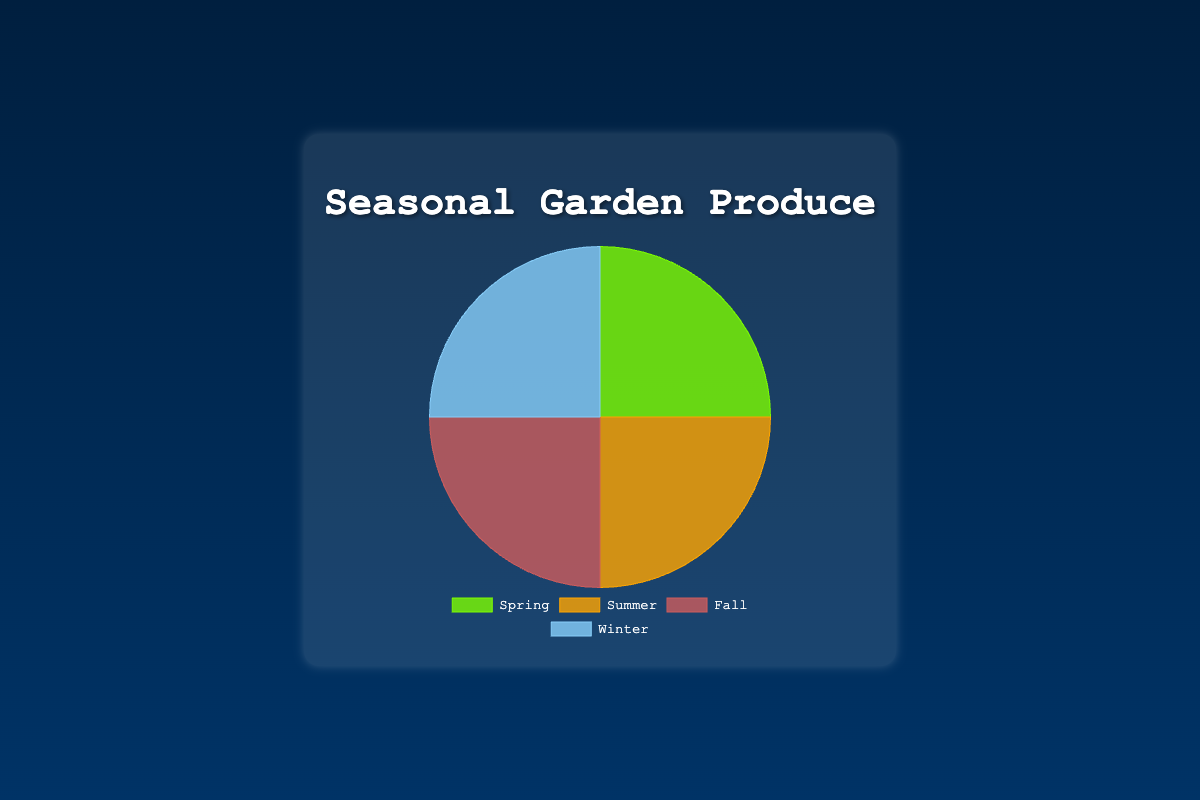Which season produces the most diverse garden output in terms of categories listed? With 4 different types of produce listed for each season, all seasons produce equally diverse outputs. The produce types are evenly distributed across Spring, Summer, Fall, and Winter.
Answer: Equal diversity across all seasons What are the products of Spring mentioned in the figure? The tooltip will display the products when hovering over the Spring section of the pie chart. Spring includes Lettuce, Radishes, Asparagus, and Strawberries.
Answer: Lettuce, Radishes, Asparagus, Strawberries Which season has the largest quantity of a single type of produce and which produce is it? We compare the quantities of individual produces across all seasons (Lettuce: 40, Radishes: 25, Asparagus: 20, Strawberries: 15, Tomatoes: 30, Zucchini: 25, Bell Peppers: 20, Blueberries: 25, Pumpkins: 35, Beets: 25, Kale: 20, Apples: 20, Brussels Sprouts: 30, Turnips: 25, Leeks: 20, Pears: 25). Pumpkins in Fall have the highest quantity of 35.
Answer: Fall, Pumpkins What is the total number of produce items in Winter? Sum the quantities of produce in Winter (Brussels Sprouts: 30, Turnips: 25, Leeks: 20, Pears: 25), giving us 30 + 25 + 20 + 25 = 100.
Answer: 100 How does the quantity of Lettuce in Spring compare to Tomatoes in Summer? Lettuce in Spring has a quantity of 40, whereas Tomatoes in Summer have a quantity of 30. So, Lettuce in Spring has more quantity compared to Tomatoes in Summer.
Answer: Lettuce in Spring has more What is the combined quantity of strawberries and blueberries? The quantity of strawberries in Spring is 15 and the quantity of blueberries in Summer is 25. Summing them up gives 15 + 25 = 40.
Answer: 40 Which season has the lowest overall produce quantity, and what is that quantity? All seasons have a total quantity of 100, hence no season has a lower total than another.
Answer: All equal with 100 If you want to grow produce in a season with the highest quantity of root vegetables, which season would you choose? Considering Radishes (25) in Spring, Beets (25) in Fall, and Turnips (25) in Winter, all tied with the highest root vegetable quantity, we should pick Spring, Fall, or Winter.
Answer: Spring, Fall, Winter What are the produce items with the second highest quantity in Summer? From the tooltip on Summer section, the produce types in Summer are Tomatoes (30), Zucchini (25), Bell Peppers (20), Blueberries (25). Zucchini and Blueberries each have the second highest quantity of 25.
Answer: Zucchini, Blueberries 